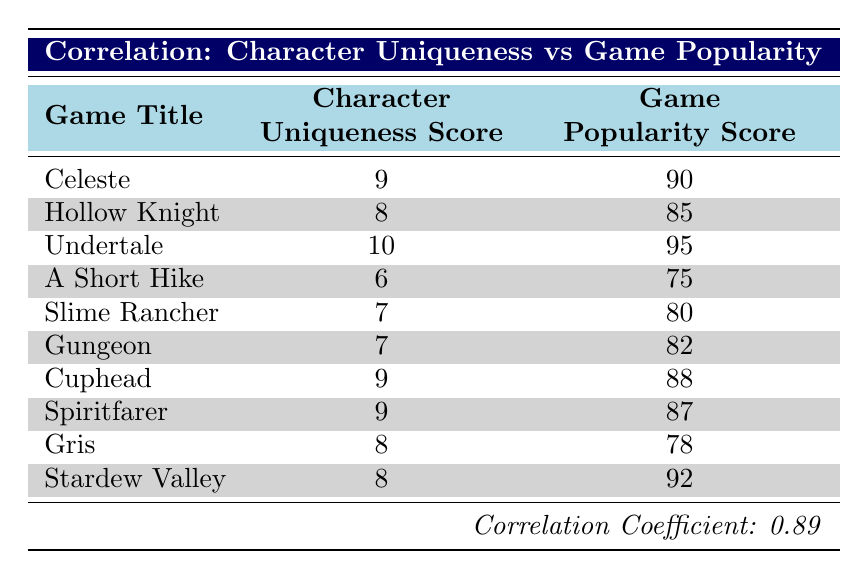What is the character uniqueness score of Undertale? According to the table, Undertale is listed with a character uniqueness score of 10.
Answer: 10 Which game has the highest game popularity score? By examining the game popularity scores listed, Undertale has the highest score at 95.
Answer: Undertale What is the average character uniqueness score of the games listed? To find the average, sum the uniqueness scores: (9 + 8 + 10 + 6 + 7 + 7 + 9 + 9 + 8 + 8) = 81. Since there are 10 games, the average is 81/10 = 8.1.
Answer: 8.1 Is the game Spiritfarer more popular than A Short Hike? Spiritfarer has a popularity score of 87, while A Short Hike has a score of 75. Since 87 is greater than 75, the answer is yes.
Answer: Yes How many games have a character uniqueness score of 8 or higher? The games with a uniqueness score of 8 or higher are Celeste, Hollow Knight, Undertale, Cuphead, Spiritfarer, Gris, and Stardew Valley, totaling 7 games.
Answer: 7 What is the difference in popularity score between the most and least popular games? The most popular game is Undertale with a score of 95, and the least popular is A Short Hike with a score of 75. The difference is 95 - 75 = 20.
Answer: 20 Which games tie with the same character uniqueness score of 9? Celeste, Cuphead, and Spiritfarer each have a character uniqueness score of 9.
Answer: Celeste, Cuphead, Spiritfarer Are all games with a character uniqueness score of 7 or higher also popular? All games listed with a score of 7 or higher have popularity scores above 75. Thus, yes, they are all popular.
Answer: Yes What is the median game popularity score among the games listed? Arranging the popularity scores in order gives us: 75, 78, 80, 82, 85, 87, 88, 90, 92, 95. The median of this sorted list (with 10 values) is the average of the 5th and 6th values: (85 + 87)/2 = 86.
Answer: 86 